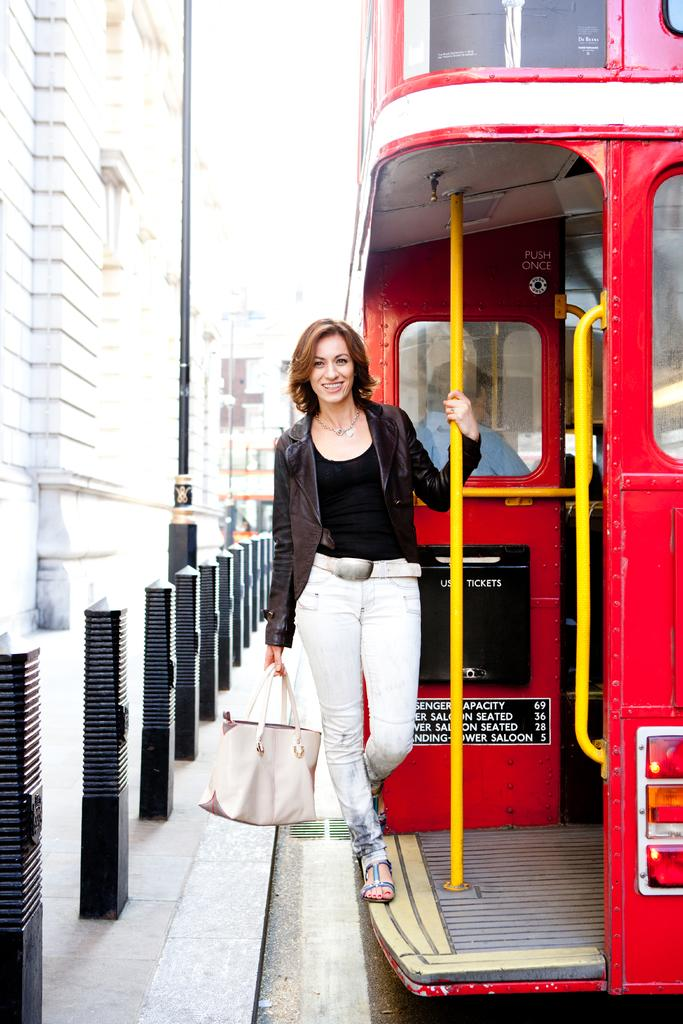Who is present in the image? There is a woman in the image. What is the woman doing in the image? The woman is smiling in the image. Where is the woman located in the image? The woman is standing on a vehicle in the image. What is the woman carrying in the image? The woman is carrying a handbag in the image. What can be seen in the background of the image? There are rods, a pole, and a building in the background of the image. How many toads can be seen on the woman's feet in the image? There are no toads present on the woman's feet in the image. In which direction is the woman facing in the image, relative to the north? The image does not provide information about the direction the woman is facing relative to the north. 